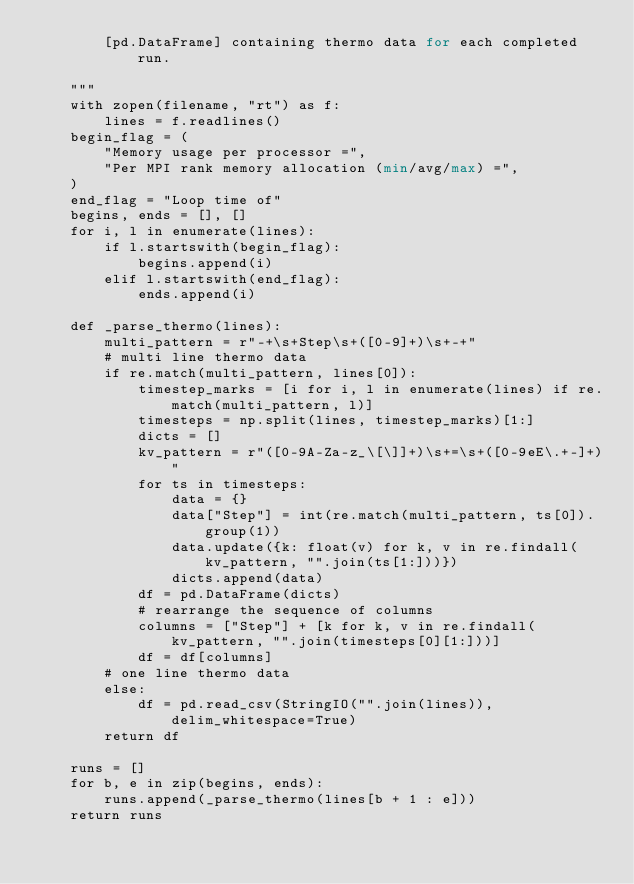<code> <loc_0><loc_0><loc_500><loc_500><_Python_>        [pd.DataFrame] containing thermo data for each completed run.

    """
    with zopen(filename, "rt") as f:
        lines = f.readlines()
    begin_flag = (
        "Memory usage per processor =",
        "Per MPI rank memory allocation (min/avg/max) =",
    )
    end_flag = "Loop time of"
    begins, ends = [], []
    for i, l in enumerate(lines):
        if l.startswith(begin_flag):
            begins.append(i)
        elif l.startswith(end_flag):
            ends.append(i)

    def _parse_thermo(lines):
        multi_pattern = r"-+\s+Step\s+([0-9]+)\s+-+"
        # multi line thermo data
        if re.match(multi_pattern, lines[0]):
            timestep_marks = [i for i, l in enumerate(lines) if re.match(multi_pattern, l)]
            timesteps = np.split(lines, timestep_marks)[1:]
            dicts = []
            kv_pattern = r"([0-9A-Za-z_\[\]]+)\s+=\s+([0-9eE\.+-]+)"
            for ts in timesteps:
                data = {}
                data["Step"] = int(re.match(multi_pattern, ts[0]).group(1))
                data.update({k: float(v) for k, v in re.findall(kv_pattern, "".join(ts[1:]))})
                dicts.append(data)
            df = pd.DataFrame(dicts)
            # rearrange the sequence of columns
            columns = ["Step"] + [k for k, v in re.findall(kv_pattern, "".join(timesteps[0][1:]))]
            df = df[columns]
        # one line thermo data
        else:
            df = pd.read_csv(StringIO("".join(lines)), delim_whitespace=True)
        return df

    runs = []
    for b, e in zip(begins, ends):
        runs.append(_parse_thermo(lines[b + 1 : e]))
    return runs
</code> 